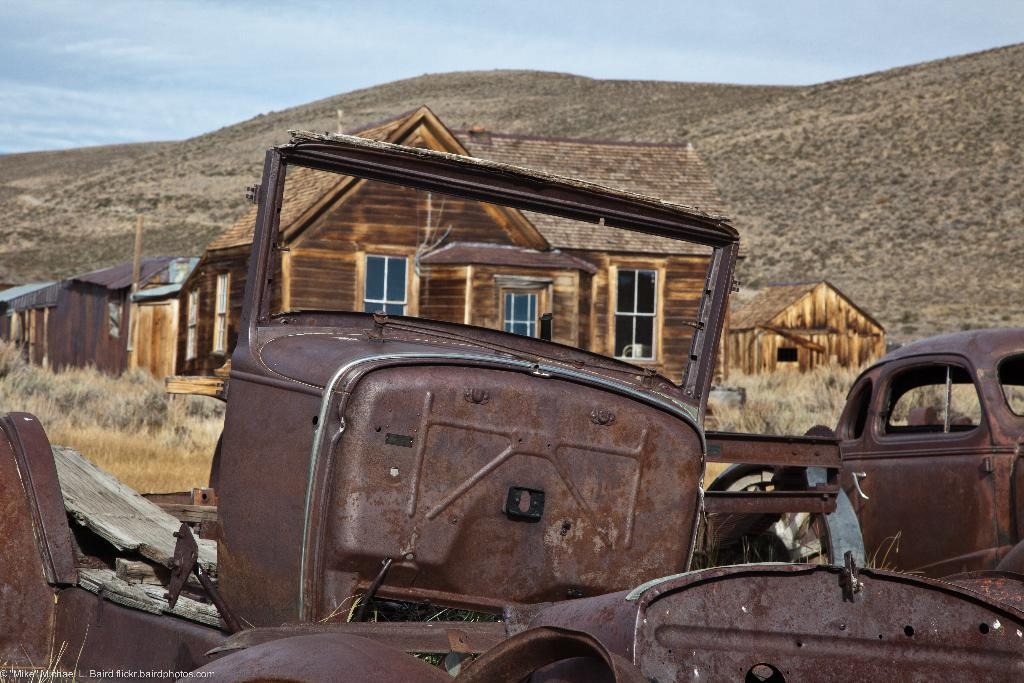What type of houses can be seen in the image? There are wooden houses in the image. What else is present in the image besides the houses? Vehicle body parts and grass are visible in the image. Are there any objects on the ground in the image? Yes, there are other objects on the ground in the image. What can be seen in the background of the image? The sky is visible in the background of the image. How many mice are running around in the image? There are no mice present in the image. Can you purchase a ticket for the downtown area in the image? There is no reference to a downtown area or tickets in the image. 